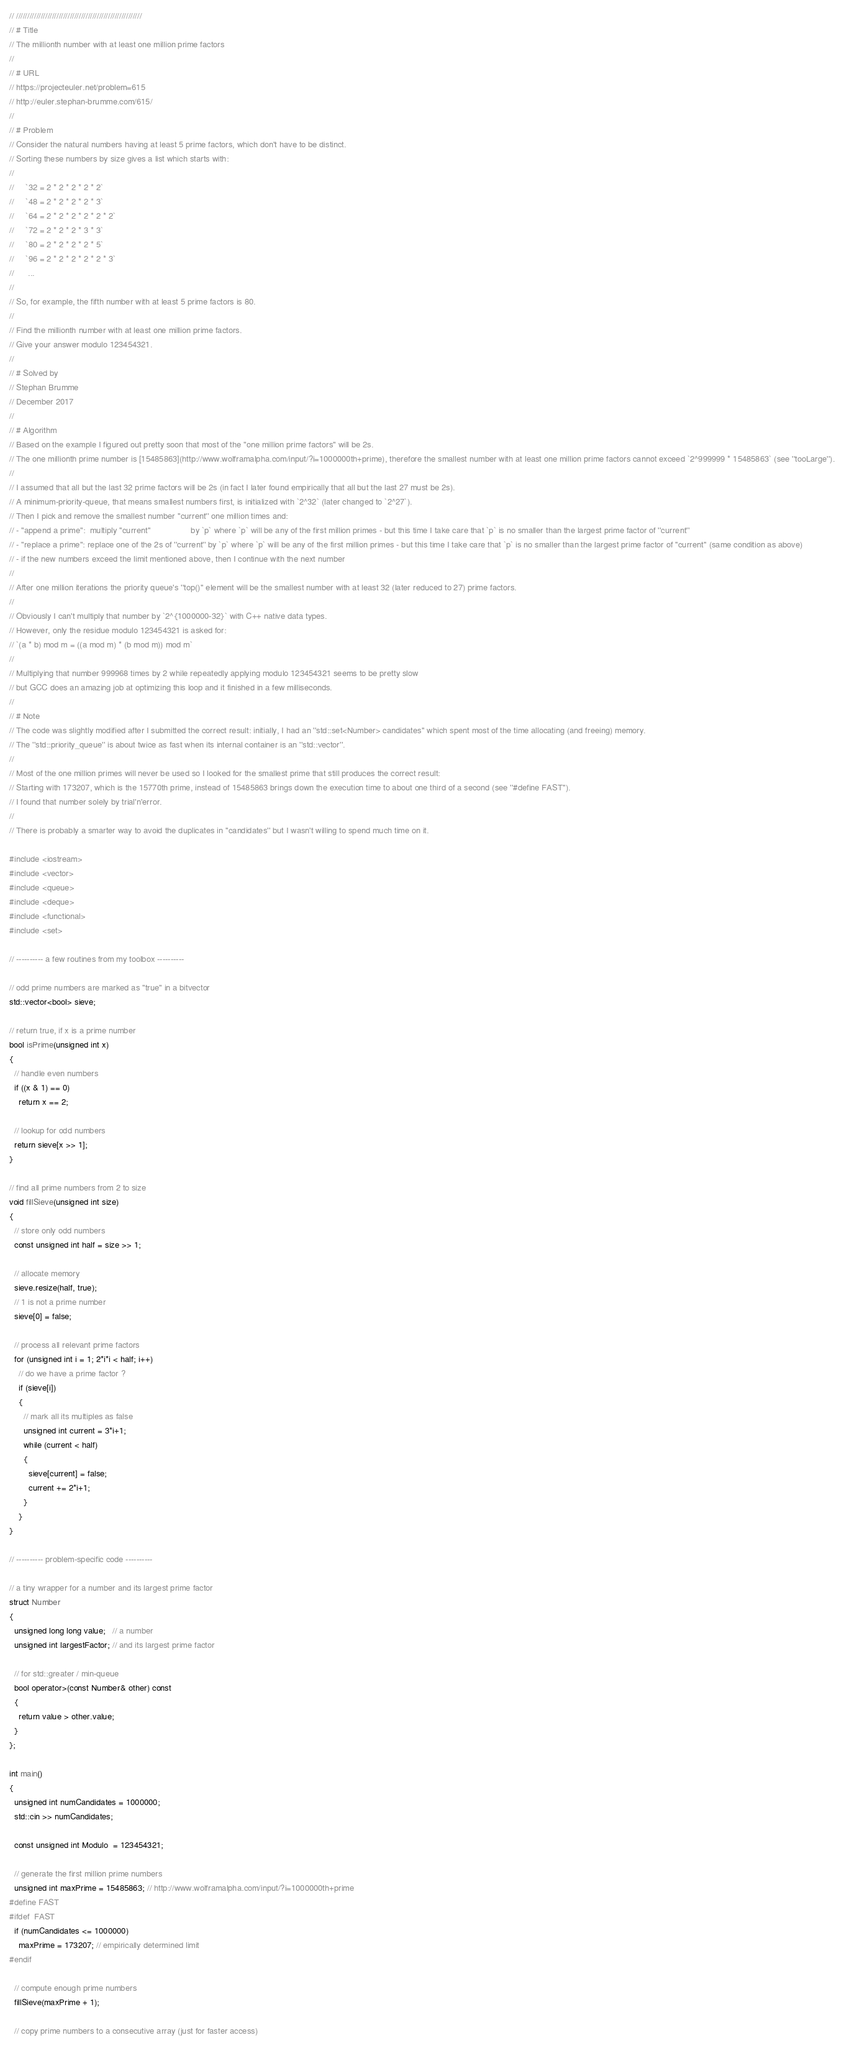Convert code to text. <code><loc_0><loc_0><loc_500><loc_500><_C++_>// ////////////////////////////////////////////////////////
// # Title
// The millionth number with at least one million prime factors
//
// # URL
// https://projecteuler.net/problem=615
// http://euler.stephan-brumme.com/615/
//
// # Problem
// Consider the natural numbers having at least 5 prime factors, which don't have to be distinct.
// Sorting these numbers by size gives a list which starts with:
//
//     `32 = 2 * 2 * 2 * 2 * 2`
//     `48 = 2 * 2 * 2 * 2 * 3`
//     `64 = 2 * 2 * 2 * 2 * 2 * 2`
//     `72 = 2 * 2 * 2 * 3 * 3`
//     `80 = 2 * 2 * 2 * 2 * 5`
//     `96 = 2 * 2 * 2 * 2 * 2 * 3`
//      ...
//
// So, for example, the fifth number with at least 5 prime factors is 80.
//
// Find the millionth number with at least one million prime factors.
// Give your answer modulo 123454321.
//
// # Solved by
// Stephan Brumme
// December 2017
//
// # Algorithm
// Based on the example I figured out pretty soon that most of the "one million prime factors" will be 2s.
// The one millionth prime number is [15485863](http://www.wolframalpha.com/input/?i=1000000th+prime), therefore the smallest number with at least one million prime factors cannot exceed `2^999999 * 15485863` (see ''tooLarge'').
//
// I assumed that all but the last 32 prime factors will be 2s (in fact I later found empirically that all but the last 27 must be 2s).
// A minimum-priority-queue, that means smallest numbers first, is initialized with `2^32` (later changed to `2^27`).
// Then I pick and remove the smallest number ''current'' one million times and:
// - "append a prime":  multiply ''current''                 by `p` where `p` will be any of the first million primes - but this time I take care that `p` is no smaller than the largest prime factor of ''current''
// - "replace a prime": replace one of the 2s of ''current'' by `p` where `p` will be any of the first million primes - but this time I take care that `p` is no smaller than the largest prime factor of ''current'' (same condition as above)
// - if the new numbers exceed the limit mentioned above, then I continue with the next number
//
// After one million iterations the priority queue's ''top()'' element will be the smallest number with at least 32 (later reduced to 27) prime factors.
//
// Obviously I can't multiply that number by `2^{1000000-32}` with C++ native data types.
// However, only the residue modulo 123454321 is asked for:
// `(a * b) mod m = ((a mod m) * (b mod m)) mod m`
//
// Multiplying that number 999968 times by 2 while repeatedly applying modulo 123454321 seems to be pretty slow
// but GCC does an amazing job at optimizing this loop and it finished in a few milliseconds.
//
// # Note
// The code was slightly modified after I submitted the correct result: initially, I had an ''std::set<Number> candidates'' which spent most of the time allocating (and freeing) memory.
// The ''std::priority_queue'' is about twice as fast when its internal container is an ''std::vector''.
//
// Most of the one million primes will never be used so I looked for the smallest prime that still produces the correct result:
// Starting with 173207, which is the 15770th prime, instead of 15485863 brings down the execution time to about one third of a second (see ''#define FAST'').
// I found that number solely by trial'n'error.
//
// There is probably a smarter way to avoid the duplicates in ''candidates'' but I wasn't willing to spend much time on it.

#include <iostream>
#include <vector>
#include <queue>
#include <deque>
#include <functional>
#include <set>

// ---------- a few routines from my toolbox ----------

// odd prime numbers are marked as "true" in a bitvector
std::vector<bool> sieve;

// return true, if x is a prime number
bool isPrime(unsigned int x)
{
  // handle even numbers
  if ((x & 1) == 0)
    return x == 2;

  // lookup for odd numbers
  return sieve[x >> 1];
}

// find all prime numbers from 2 to size
void fillSieve(unsigned int size)
{
  // store only odd numbers
  const unsigned int half = size >> 1;

  // allocate memory
  sieve.resize(half, true);
  // 1 is not a prime number
  sieve[0] = false;

  // process all relevant prime factors
  for (unsigned int i = 1; 2*i*i < half; i++)
    // do we have a prime factor ?
    if (sieve[i])
    {
      // mark all its multiples as false
      unsigned int current = 3*i+1;
      while (current < half)
      {
        sieve[current] = false;
        current += 2*i+1;
      }
    }
}

// ---------- problem-specific code ----------

// a tiny wrapper for a number and its largest prime factor
struct Number
{
  unsigned long long value;   // a number
  unsigned int largestFactor; // and its largest prime factor

  // for std::greater / min-queue
  bool operator>(const Number& other) const
  {
    return value > other.value;
  }
};

int main()
{
  unsigned int numCandidates = 1000000;
  std::cin >> numCandidates;

  const unsigned int Modulo  = 123454321;

  // generate the first million prime numbers
  unsigned int maxPrime = 15485863; // http://www.wolframalpha.com/input/?i=1000000th+prime
#define FAST
#ifdef  FAST
  if (numCandidates <= 1000000)
    maxPrime = 173207; // empirically determined limit
#endif

  // compute enough prime numbers
  fillSieve(maxPrime + 1);

  // copy prime numbers to a consecutive array (just for faster access)</code> 